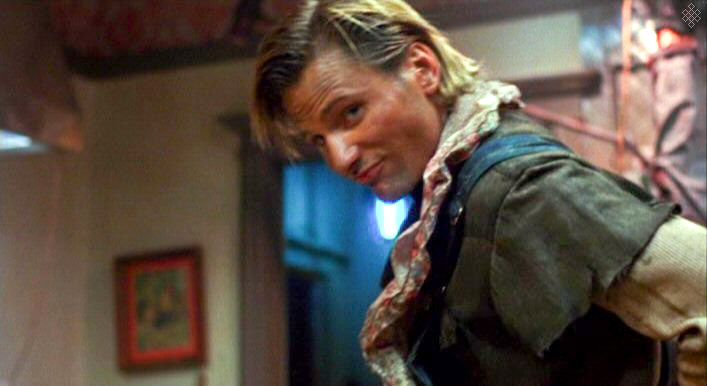What's happening in the scene? The image captures a man glancing over his shoulder with a subtle, intrigued expression. He is dressed in a rugged, layered outfit with a beige jacket, a blue shirt underneath, and a patterned scarf. The dimly lit indoor setting appears rustic and slightly aged, with a wooden beam visible overhead and a colorful painting on the wall in the background, contributing to an atmosphere of informal warmth. 